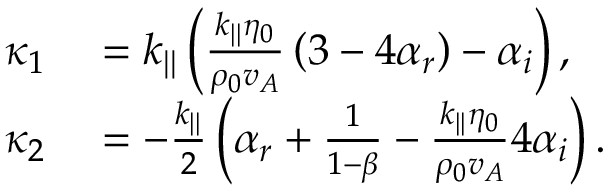Convert formula to latex. <formula><loc_0><loc_0><loc_500><loc_500>\begin{array} { r l } { \kappa _ { 1 } } & = k _ { | | } \left ( \frac { k _ { | | } \eta _ { 0 } } { \rho _ { 0 } v _ { A } } \left ( 3 - 4 \alpha _ { r } \right ) - \alpha _ { i } \right ) , } \\ { \kappa _ { 2 } } & = - \frac { k _ { | | } } { 2 } \left ( \alpha _ { r } + \frac { 1 } { 1 - \beta } - \frac { k _ { | | } \eta _ { 0 } } { \rho _ { 0 } v _ { A } } 4 \alpha _ { i } \right ) . } \end{array}</formula> 